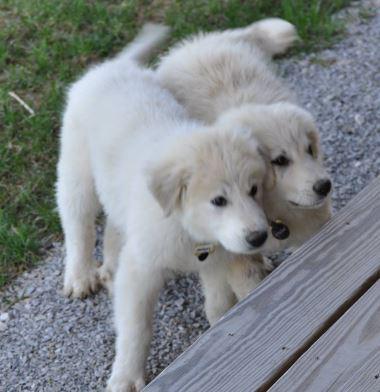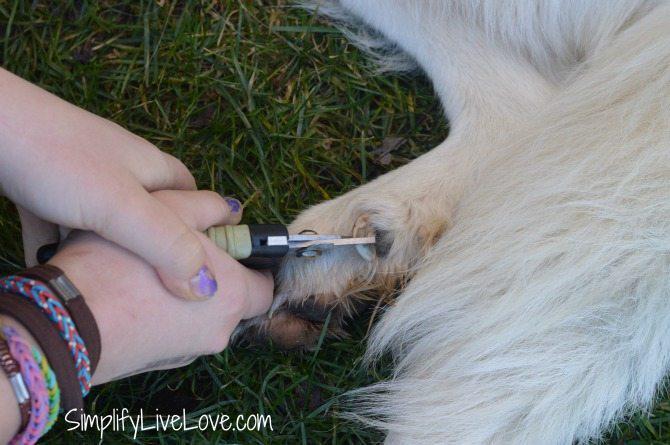The first image is the image on the left, the second image is the image on the right. Analyze the images presented: Is the assertion "A girl wearing a blue shirt and sunglasses is sitting in between 2 large white dogs." valid? Answer yes or no. No. 